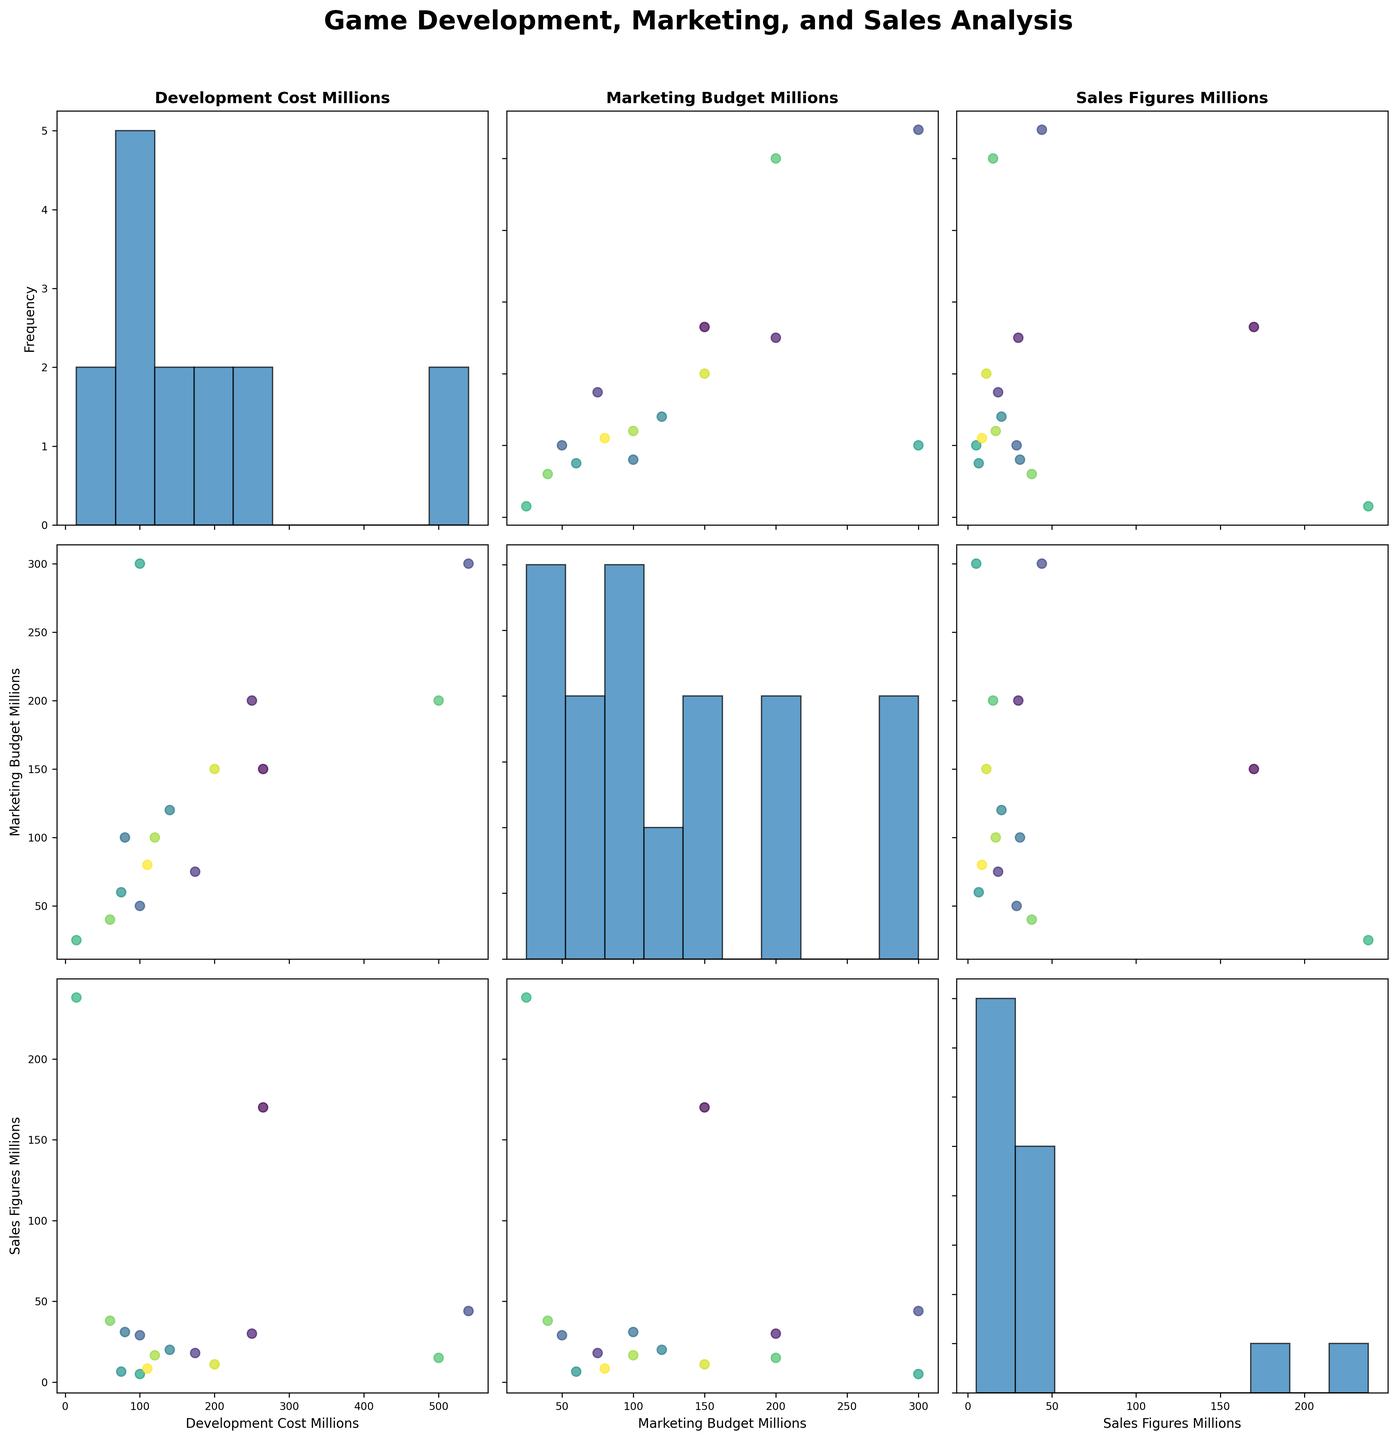How many data points are plotted in each scatterplot and histogram? Each scatterplot and histogram represents data for 15 games, so each scatterplot contains 15 points, and each histogram contains the counts for 15 data points.
Answer: 15 What is the title of the figure? The title of the figure is located at the top center and reads "Game Development, Marketing, and Sales Analysis."
Answer: Game Development, Marketing, and Sales Analysis Which variable has the highest peak frequency in its histogram? By examining the histograms, the variable "Sales_Figures_Millions" has the highest peak frequency, with sales concentrated around lower values.
Answer: Sales_Figures_Millions If a game has a high development cost, what can generally be inferred about its sales figures? Scatterplots show that some games with high development costs do not necessarily have high sales figures, e.g., "Red Dead Redemption 2" with high development cost and lower sales compared to "Minecraft."
Answer: Mixed correlation Does higher marketing budget positively correlate with higher sales figures? The scatterplot between "Marketing_Budget_Millions" and "Sales_Figures_Millions" shows no strong positive correlation, as some high-budget games have low sales.
Answer: No What is the most expensive game in terms of development costs? From the "Development_Cost_Millions" histogram, the highest cost is 540 million for "Red Dead Redemption 2."
Answer: Red Dead Redemption 2 Do games with lower development costs always have higher sales figures? Observing the scatterplots between "Development_Cost_Millions" and "Sales_Figures_Millions," it is evident that lower development costs do not always correspond with higher sales, as shown by games like "Minecraft" and "Animal Crossing: New Horizons."
Answer: No How do development costs compare to marketing budgets across the dataset? By examining the scatterplots of "Development_Cost_Millions" vs. "Marketing_Budget_Millions," it is clear that some games have higher marketing budgets compared to development costs and vice versa, there is no uniform pattern.
Answer: Mixed Which pair of variables shows the least correlation visually? The scatterplot between "Marketing_Budget_Millions" and "Sales_Figures_Millions" appears to show the least apparent correlation among the three variable pairs.
Answer: Marketing_Budget vs Sales_Figures 